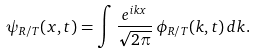<formula> <loc_0><loc_0><loc_500><loc_500>\psi _ { R / T } ( x , t ) = \int \frac { e ^ { i k x } } { \sqrt { 2 \pi } } \, \phi _ { R / T } ( k , t ) \, d k .</formula> 